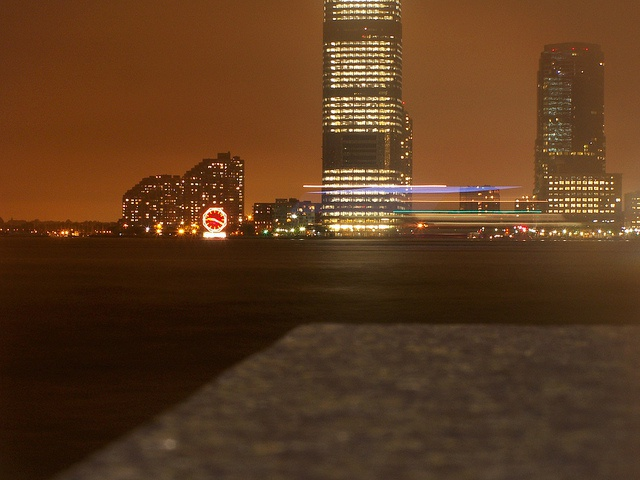Describe the objects in this image and their specific colors. I can see a clock in maroon, red, ivory, and khaki tones in this image. 